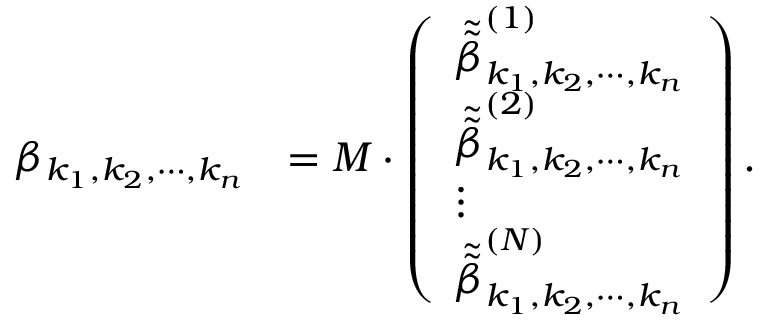Convert formula to latex. <formula><loc_0><loc_0><loc_500><loc_500>\begin{array} { r l } { \beta _ { k _ { 1 } , k _ { 2 } , \cdots , k _ { n } } } & { = M \cdot \left ( \begin{array} { l } { \tilde { \tilde { \beta } } _ { k _ { 1 } , k _ { 2 } , \cdots , k _ { n } } ^ { ( 1 ) } } \\ { \tilde { \tilde { \beta } } _ { k _ { 1 } , k _ { 2 } , \cdots , k _ { n } } ^ { ( 2 ) } } \\ { \vdots } \\ { \tilde { \tilde { \beta } } _ { k _ { 1 } , k _ { 2 } , \cdots , k _ { n } } ^ { ( N ) } } \end{array} \right ) . } \end{array}</formula> 